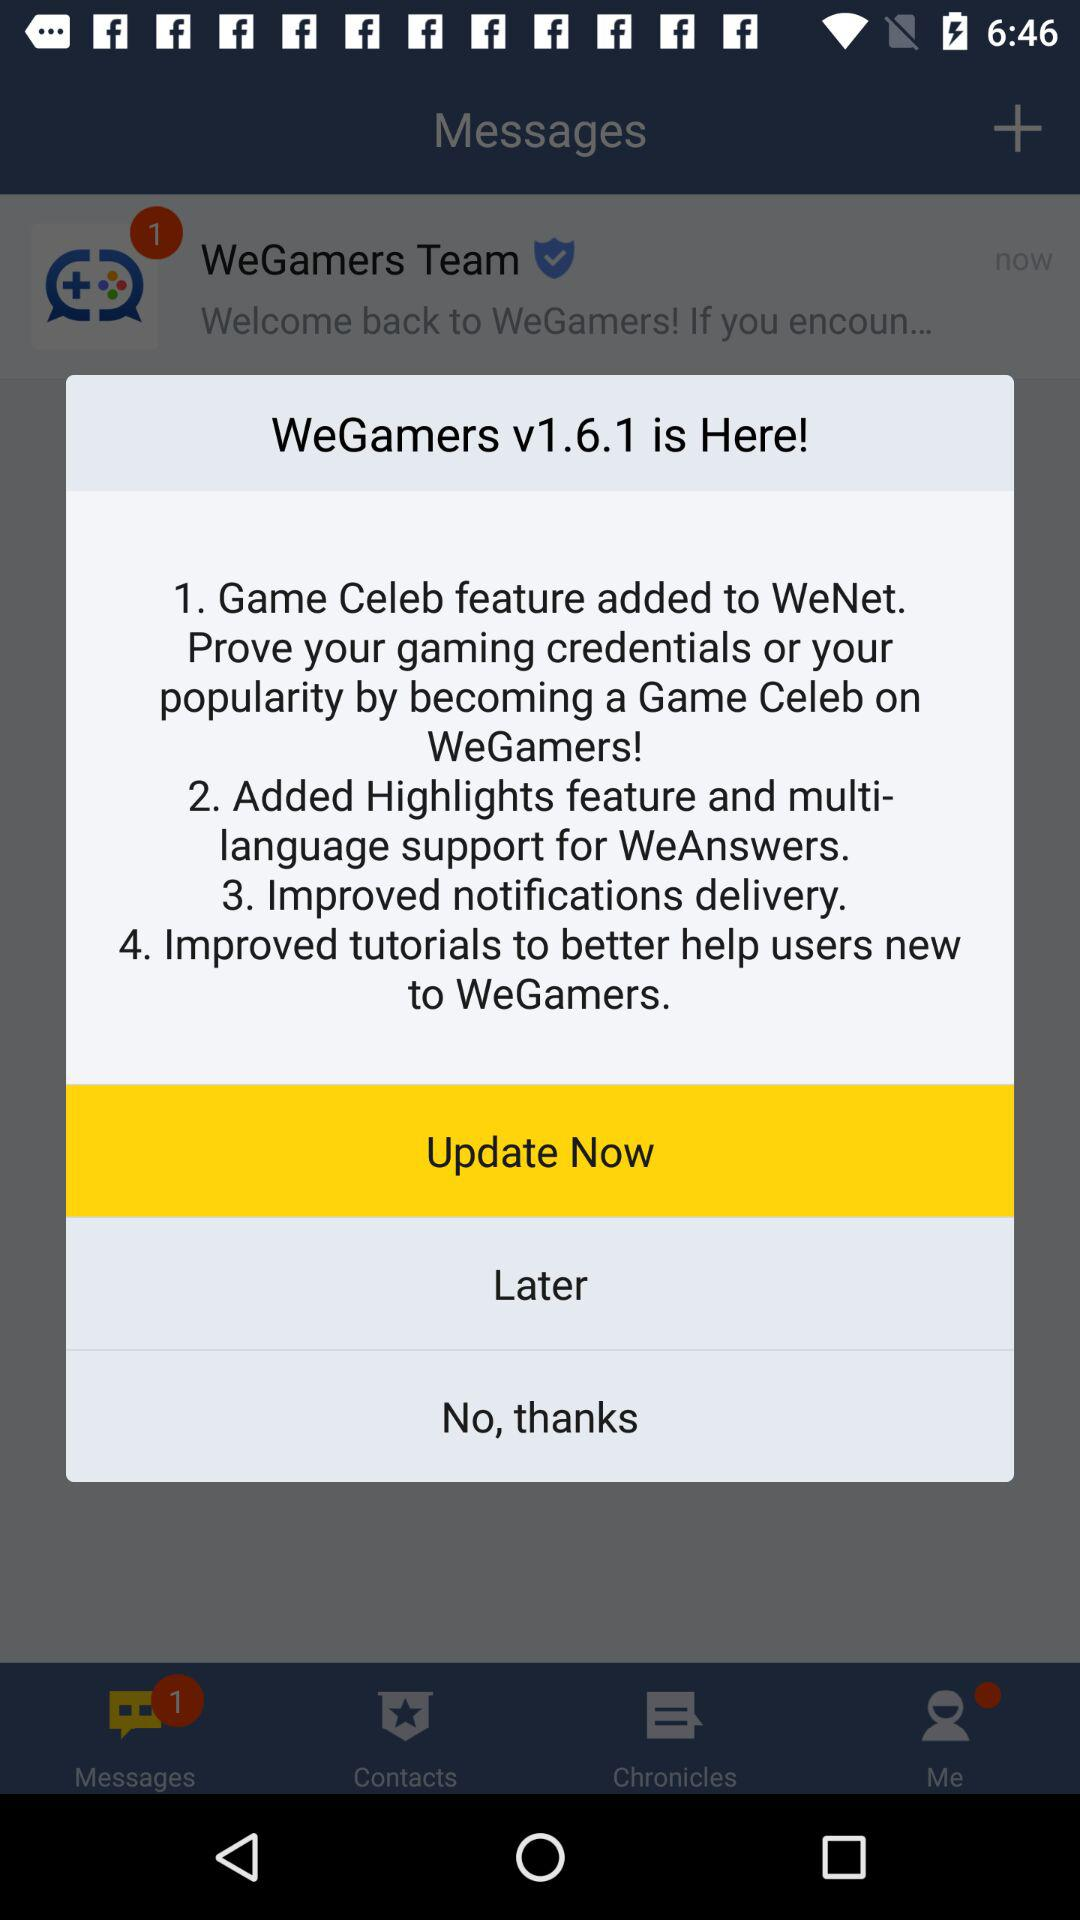What is the version? The version is v1.6.1. 